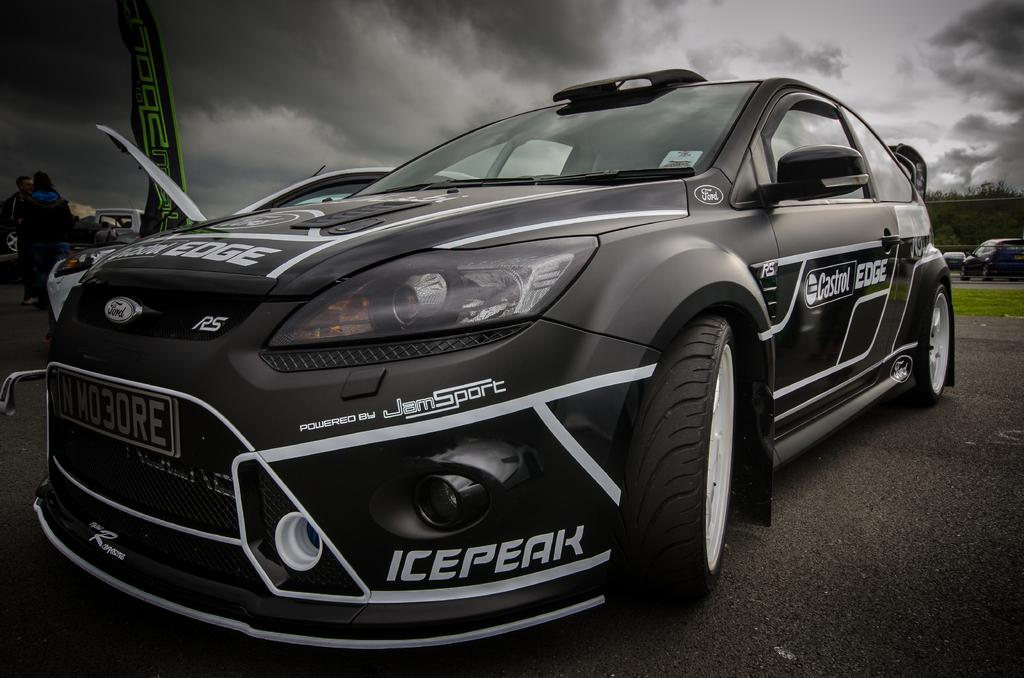What is the main subject in the foreground of the image? There is a car in the foreground of the image. Can you describe the position of the car in the image? The car is on the ground. What can be seen in the background of the image? There is grass, vehicles, trees, a flag, and people in the background of the image. What is visible in the sky in the image? The sky is visible in the image, and there are clouds present. What type of wire is being used by the muscle in the image? There is no wire or muscle present in the image; it features a car in the foreground and various elements in the background. 